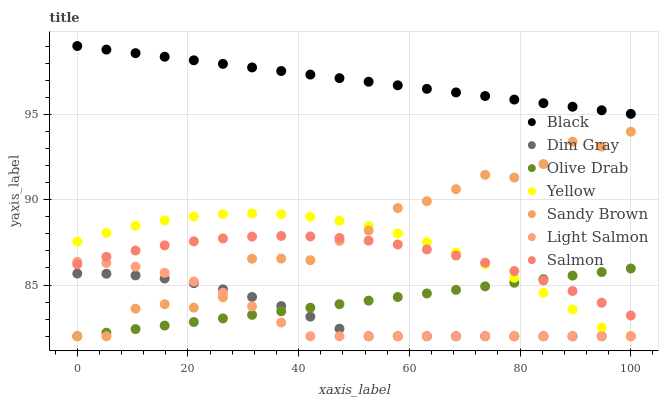Does Light Salmon have the minimum area under the curve?
Answer yes or no. Yes. Does Black have the maximum area under the curve?
Answer yes or no. Yes. Does Dim Gray have the minimum area under the curve?
Answer yes or no. No. Does Dim Gray have the maximum area under the curve?
Answer yes or no. No. Is Olive Drab the smoothest?
Answer yes or no. Yes. Is Sandy Brown the roughest?
Answer yes or no. Yes. Is Dim Gray the smoothest?
Answer yes or no. No. Is Dim Gray the roughest?
Answer yes or no. No. Does Light Salmon have the lowest value?
Answer yes or no. Yes. Does Salmon have the lowest value?
Answer yes or no. No. Does Black have the highest value?
Answer yes or no. Yes. Does Salmon have the highest value?
Answer yes or no. No. Is Olive Drab less than Black?
Answer yes or no. Yes. Is Black greater than Sandy Brown?
Answer yes or no. Yes. Does Olive Drab intersect Sandy Brown?
Answer yes or no. Yes. Is Olive Drab less than Sandy Brown?
Answer yes or no. No. Is Olive Drab greater than Sandy Brown?
Answer yes or no. No. Does Olive Drab intersect Black?
Answer yes or no. No. 